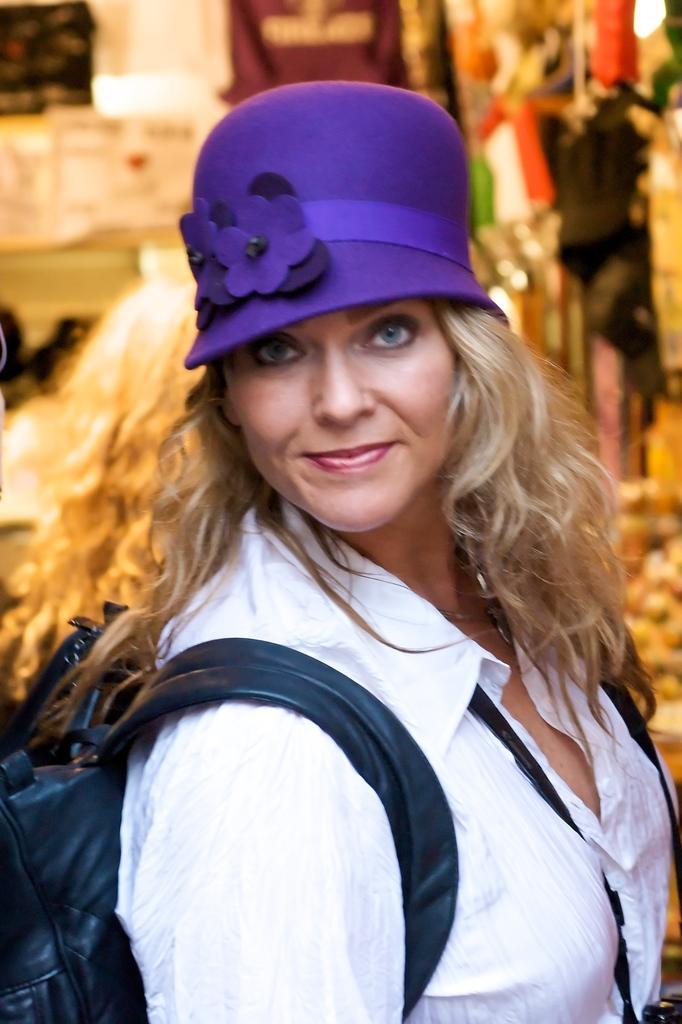How would you summarize this image in a sentence or two? A woman is carrying a bag and an object on her shoulders and neck and there is a cap on her head. In the background the image is blur but we can see clothes and other objects. 